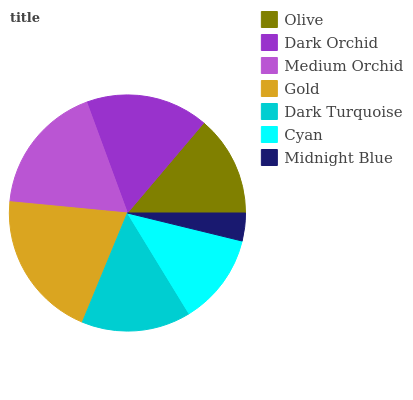Is Midnight Blue the minimum?
Answer yes or no. Yes. Is Gold the maximum?
Answer yes or no. Yes. Is Dark Orchid the minimum?
Answer yes or no. No. Is Dark Orchid the maximum?
Answer yes or no. No. Is Dark Orchid greater than Olive?
Answer yes or no. Yes. Is Olive less than Dark Orchid?
Answer yes or no. Yes. Is Olive greater than Dark Orchid?
Answer yes or no. No. Is Dark Orchid less than Olive?
Answer yes or no. No. Is Dark Turquoise the high median?
Answer yes or no. Yes. Is Dark Turquoise the low median?
Answer yes or no. Yes. Is Midnight Blue the high median?
Answer yes or no. No. Is Medium Orchid the low median?
Answer yes or no. No. 